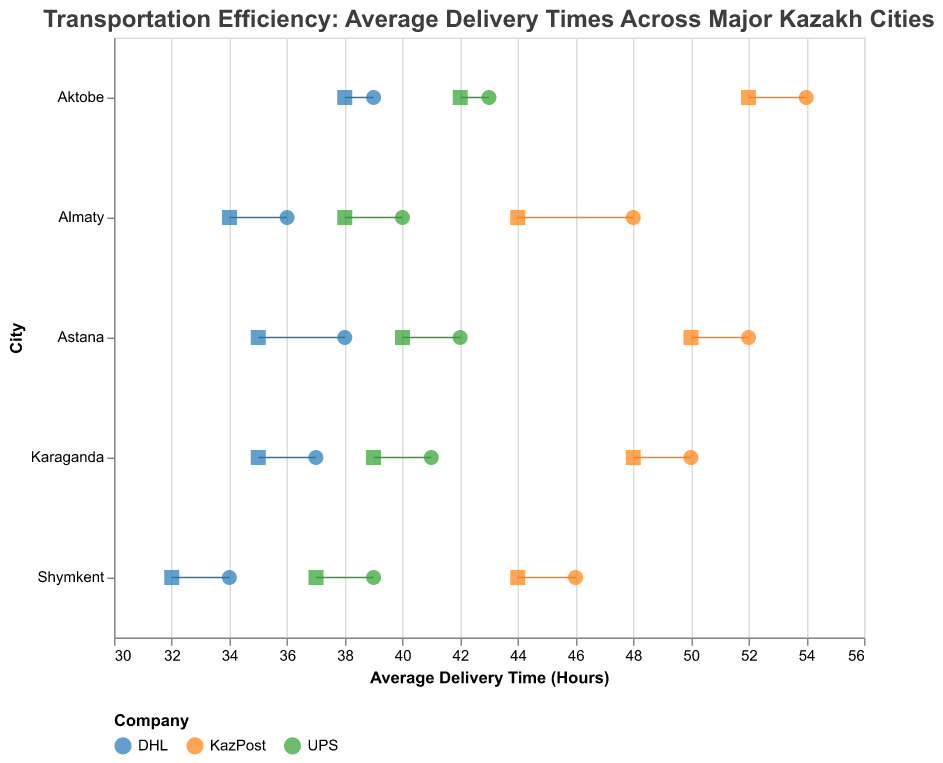What is the title of the plot? The title is simply written at the top of the plot.
Answer: "Transportation Efficiency: Average Delivery Times Across Major Kazakh Cities" What are the average delivery times for KazPost in Almaty for the years 2021 and 2022? The average delivery times are shown on the x-axis under the respective points for 2021 (circle) and 2022 (square), and color-coded by Company.
Answer: 48 hours (2021), 44 hours (2022) Which company has the shortest average delivery time in Astana in 2022? Compare the positions of different companies' squares on the year 2022 axis; the furthest left indicates the shortest average delivery time.
Answer: DHL How much did the delivery time for UPS in Karaganda change from 2021 to 2022? Subtract the value of 2022 from 2021 for UPS in Karaganda (41 - 39).
Answer: 2 hours Which city had the largest reduction in average delivery times for DHL from 2021 to 2022? Find the city with the largest difference between the circles and squares for DHL.
Answer: Astana What is the difference in average delivery times in Shymkent between KazPost and UPS for the year 2022? Subtract the 2022 average delivery time of UPS from KazPost in Shymkent (44 - 37).
Answer: 7 hours In which city did KazPost have the highest average delivery time for 2021? Identify the highest position on the x-axis for the KazPost circle.
Answer: Aktobe How did the average delivery times for DHL vary between Karaganda and Aktobe in 2021? Compare the x-position of the DHL circles in 2021 for both cities.
Answer: Karaganda: 37 hours, Aktobe: 39 hours Which company's delivery time remained closest to the same between 2021 and 2022 across all cities? Observe which company's data points show the least displacement between the circle and square markers across all cities.
Answer: DHL What is the average delivery time for UPS in Astana for both years combined? Add the average delivery times for UPS in 2021 and 2022 in Astana, then divide by 2 ((42 + 40) / 2).
Answer: 41 hours 